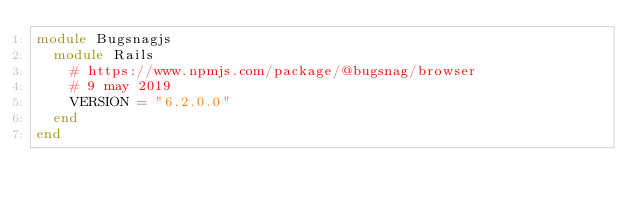Convert code to text. <code><loc_0><loc_0><loc_500><loc_500><_Ruby_>module Bugsnagjs
  module Rails
    # https://www.npmjs.com/package/@bugsnag/browser
    # 9 may 2019
    VERSION = "6.2.0.0"
  end
end
</code> 